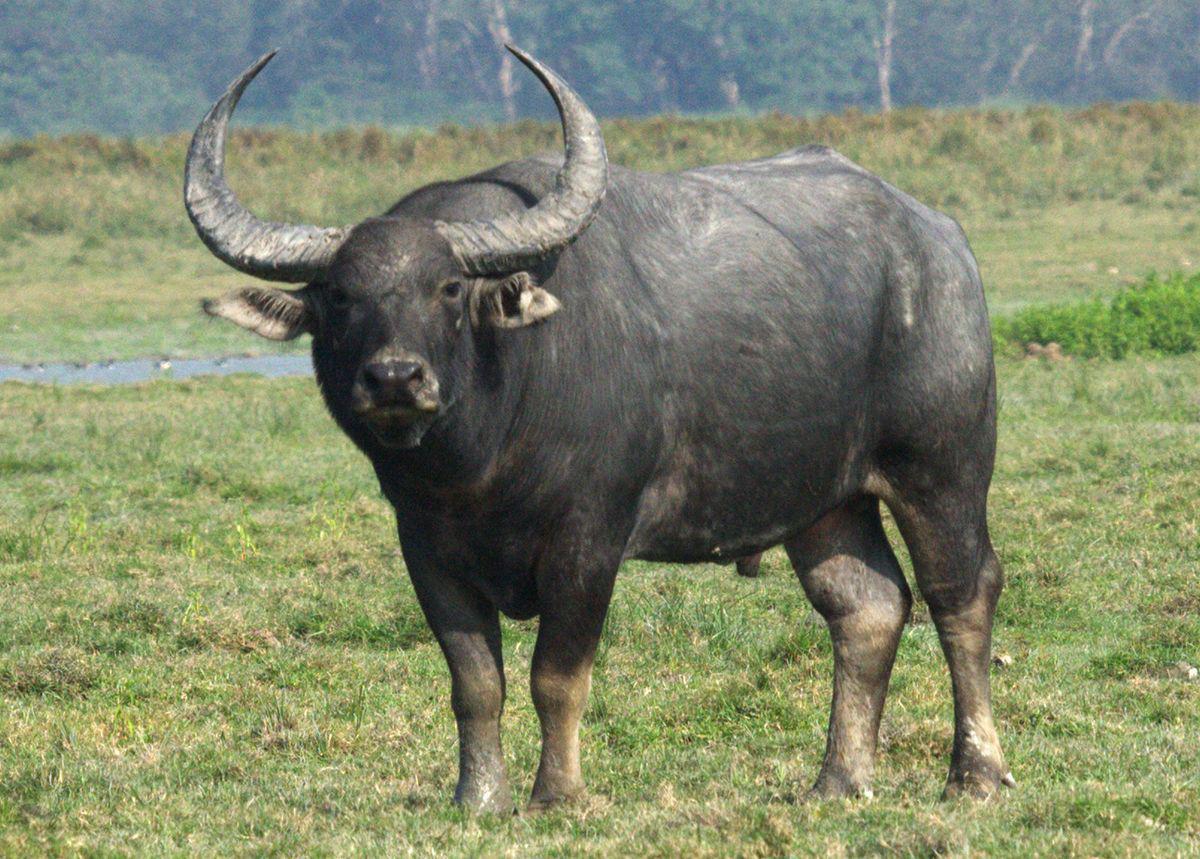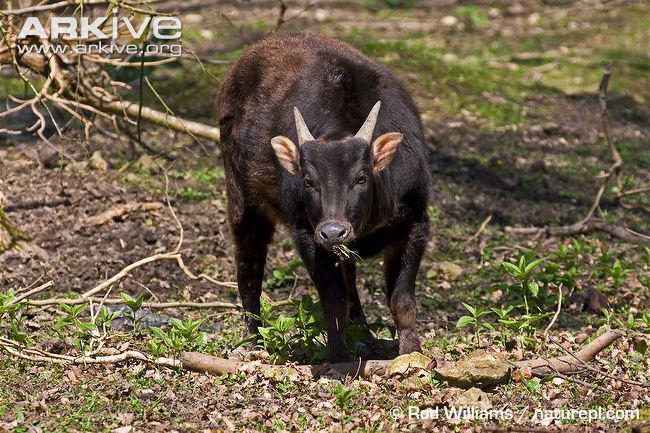The first image is the image on the left, the second image is the image on the right. For the images shown, is this caption "A body of water is visible in the right image of a water buffalo." true? Answer yes or no. No. The first image is the image on the left, the second image is the image on the right. Given the left and right images, does the statement "There is a large black yak in the water." hold true? Answer yes or no. No. 